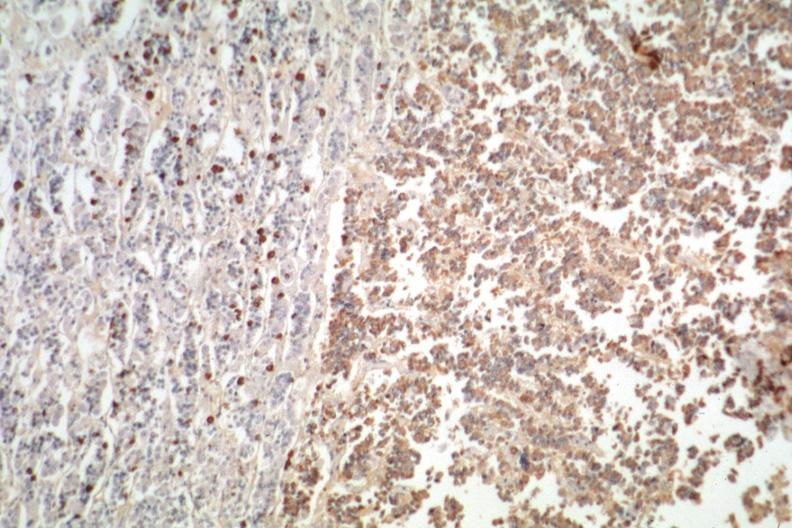s endocrine present?
Answer the question using a single word or phrase. Yes 